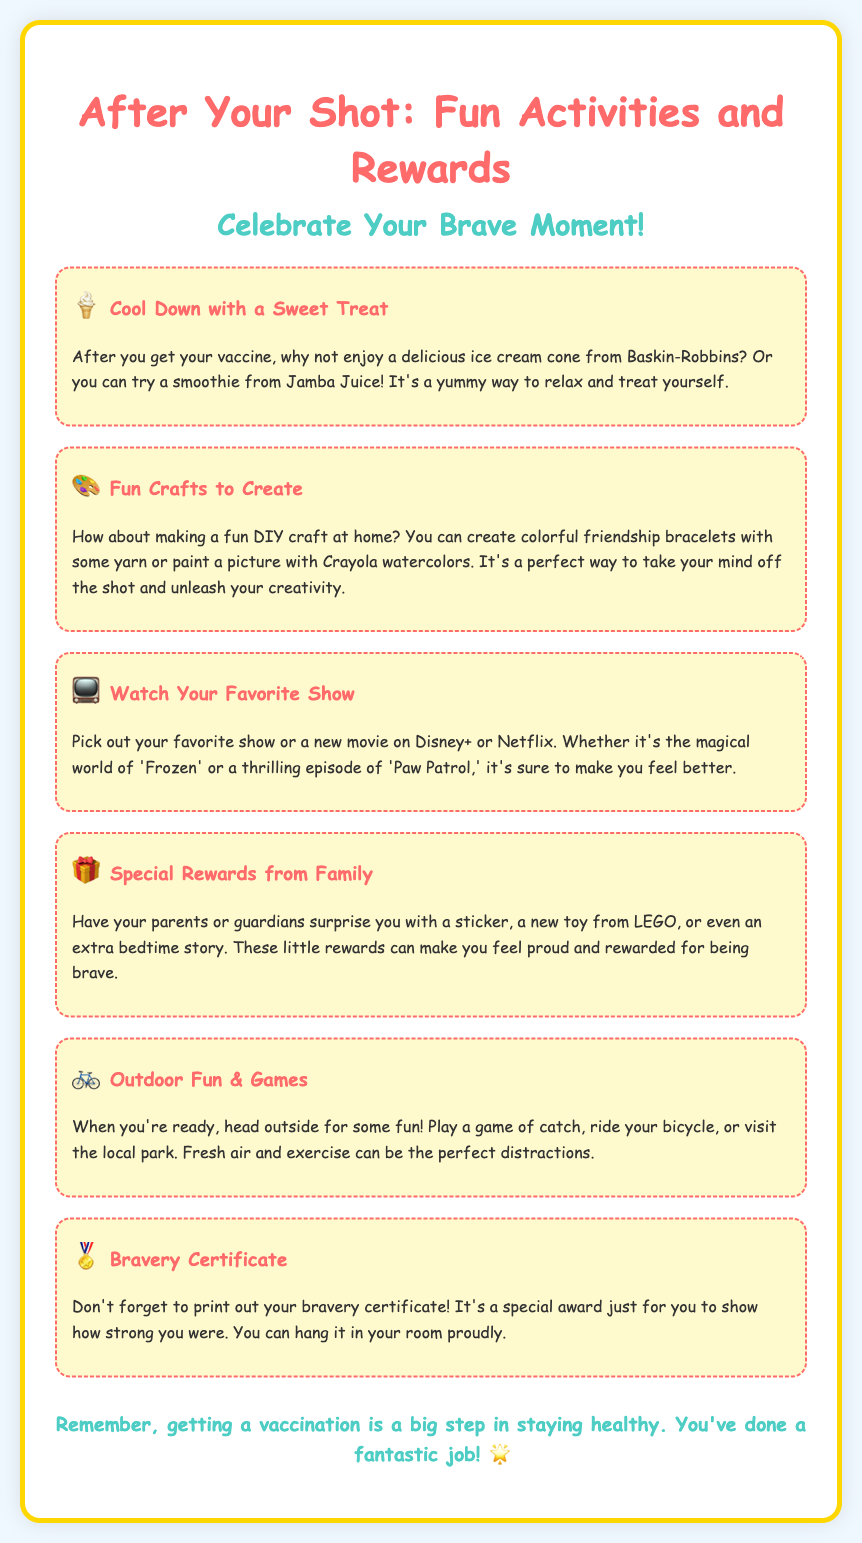What is a fun treat mentioned after the shot? The document lists ice cream from Baskin-Robbins and smoothies from Jamba Juice as fun treats.
Answer: ice cream and smoothies What activity involves making friendship bracelets? This activity is categorized under the Fun Crafts section that suggests making DIY crafts at home.
Answer: Fun Crafts What can you do outside after your shot? The document suggests playing catch, riding a bicycle, or visiting the local park.
Answer: play catch, ride a bicycle, or visit the local park What can parents give as special rewards? Parents can surprise children with stickers, toys from LEGO, or bedtime stories as rewards.
Answer: stickers, toys, or bedtime stories Which TV show streaming service is mentioned? The document mentions Disney+ and Netflix as options for watching favorite shows or movies.
Answer: Disney+ and Netflix What is the purpose of the bravery certificate? The bravery certificate serves as a special award to recognize the child's bravery after getting the vaccine.
Answer: recognition of bravery What type of activities are suggested to take your mind off the shot? The document suggests fun crafts, watching shows, and outdoor games as activities to distract from the shot.
Answer: fun crafts, watching shows, and outdoor games What is the main theme of the flyer? The flyer promotes fun activities and rewards for children after receiving their vaccination shot.
Answer: fun activities and rewards What is the color of the heading text? The heading text is colored in a specific shade of pinkish-red mentioned in the design details.
Answer: pinkish-red 